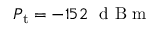<formula> <loc_0><loc_0><loc_500><loc_500>P _ { t } = - 1 5 2 \ d B m</formula> 